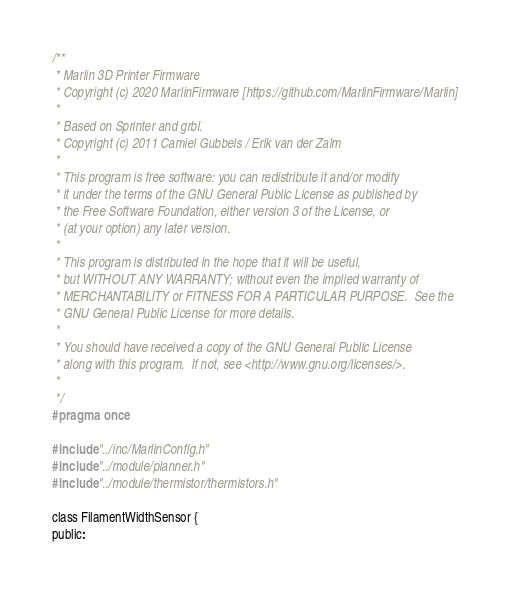<code> <loc_0><loc_0><loc_500><loc_500><_C_>/**
 * Marlin 3D Printer Firmware
 * Copyright (c) 2020 MarlinFirmware [https://github.com/MarlinFirmware/Marlin]
 *
 * Based on Sprinter and grbl.
 * Copyright (c) 2011 Camiel Gubbels / Erik van der Zalm
 *
 * This program is free software: you can redistribute it and/or modify
 * it under the terms of the GNU General Public License as published by
 * the Free Software Foundation, either version 3 of the License, or
 * (at your option) any later version.
 *
 * This program is distributed in the hope that it will be useful,
 * but WITHOUT ANY WARRANTY; without even the implied warranty of
 * MERCHANTABILITY or FITNESS FOR A PARTICULAR PURPOSE.  See the
 * GNU General Public License for more details.
 *
 * You should have received a copy of the GNU General Public License
 * along with this program.  If not, see <http://www.gnu.org/licenses/>.
 *
 */
#pragma once

#include "../inc/MarlinConfig.h"
#include "../module/planner.h"
#include "../module/thermistor/thermistors.h"

class FilamentWidthSensor {
public:</code> 